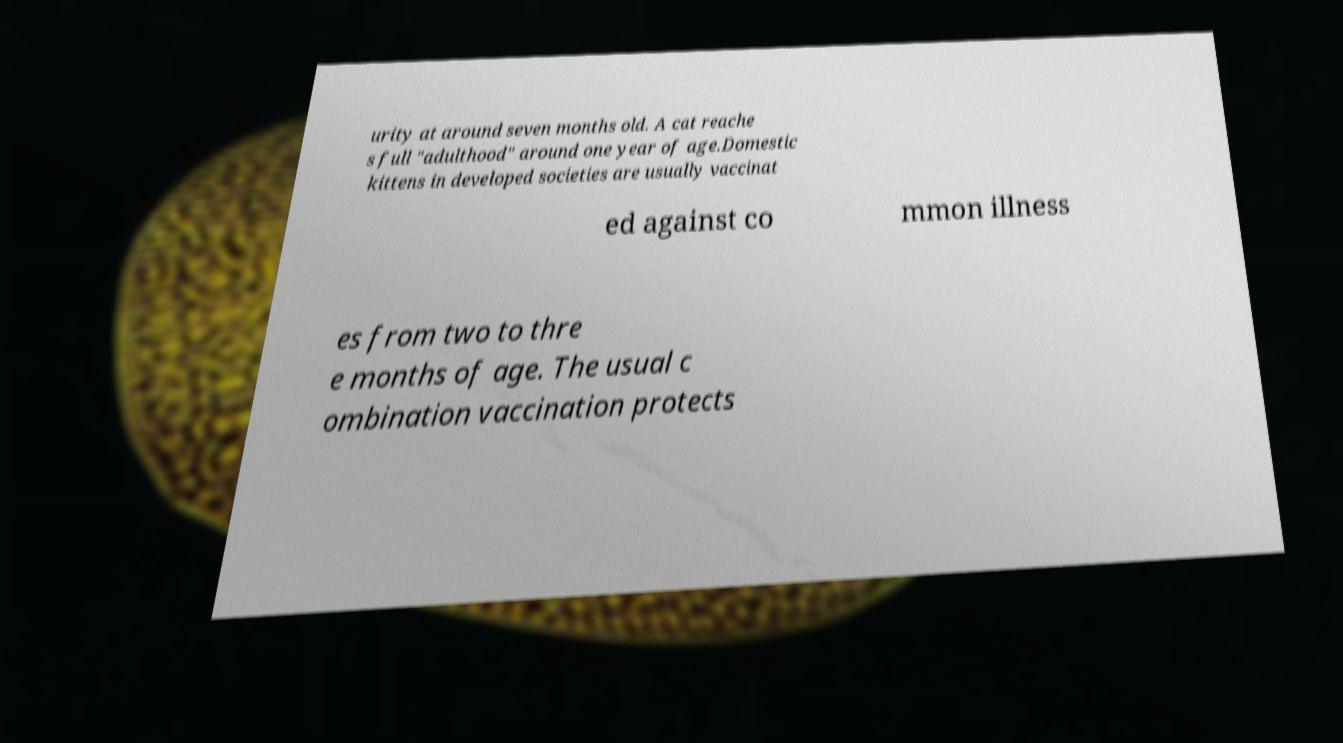Please identify and transcribe the text found in this image. urity at around seven months old. A cat reache s full "adulthood" around one year of age.Domestic kittens in developed societies are usually vaccinat ed against co mmon illness es from two to thre e months of age. The usual c ombination vaccination protects 